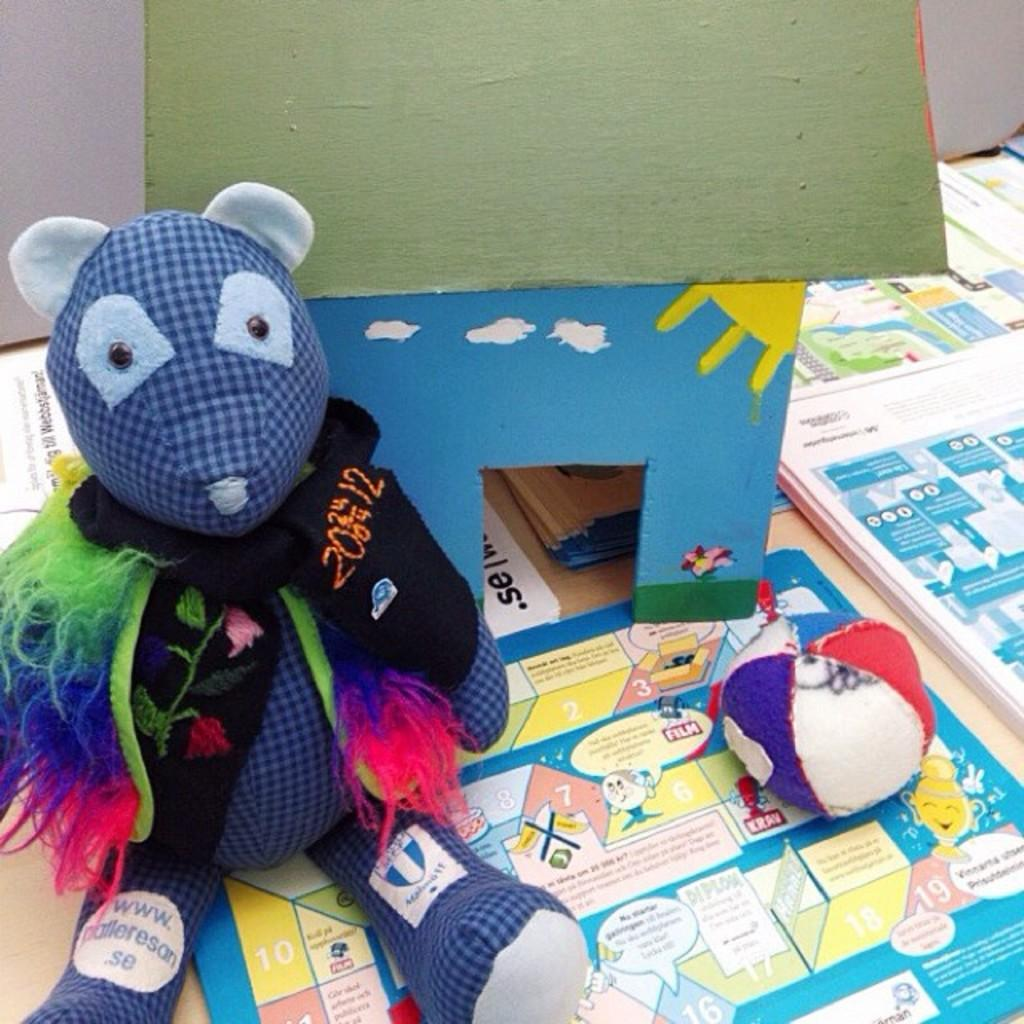What objects can be seen in the image? There are toys and papers in the image. Where are the toys and papers located? The toys and papers are on a platform. What can be seen in the background of the image? There are cardboard sheets in the background of the image. How many beans are in the cup in the image? There is no cup or beans present in the image. What type of arithmetic problem is being solved on the papers in the image? There is no arithmetic problem visible on the papers in the image. 